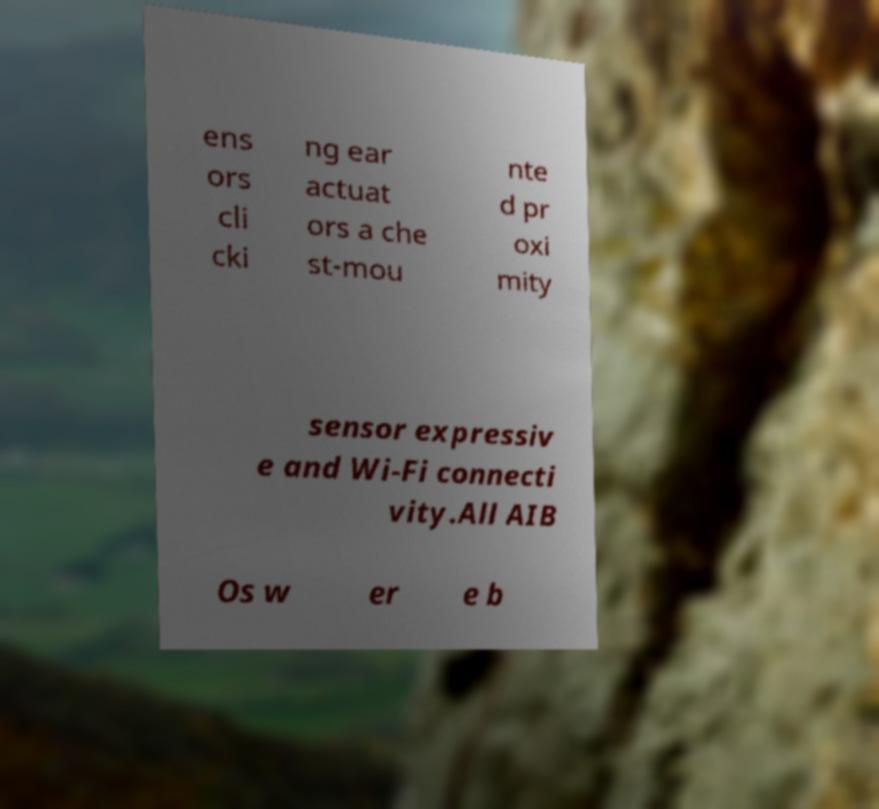For documentation purposes, I need the text within this image transcribed. Could you provide that? ens ors cli cki ng ear actuat ors a che st-mou nte d pr oxi mity sensor expressiv e and Wi-Fi connecti vity.All AIB Os w er e b 